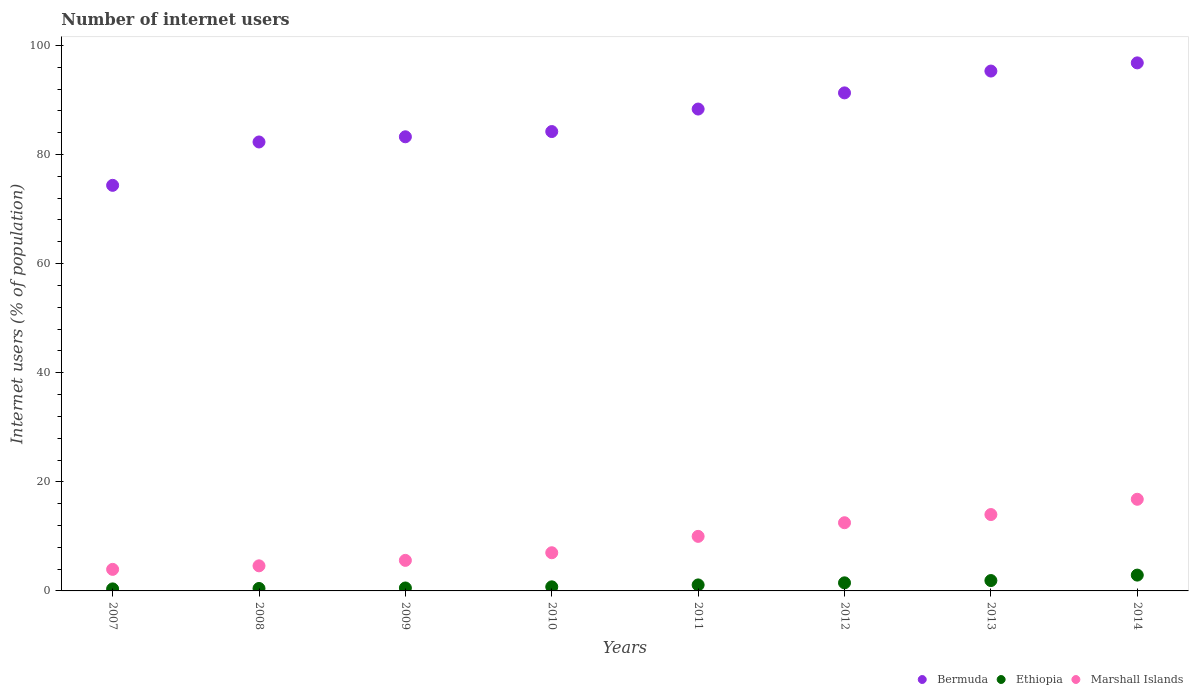Is the number of dotlines equal to the number of legend labels?
Make the answer very short. Yes. What is the number of internet users in Bermuda in 2010?
Provide a succinct answer. 84.21. Across all years, what is the maximum number of internet users in Ethiopia?
Offer a terse response. 2.9. Across all years, what is the minimum number of internet users in Marshall Islands?
Ensure brevity in your answer.  3.95. In which year was the number of internet users in Bermuda maximum?
Your answer should be compact. 2014. In which year was the number of internet users in Bermuda minimum?
Ensure brevity in your answer.  2007. What is the total number of internet users in Marshall Islands in the graph?
Ensure brevity in your answer.  74.45. What is the difference between the number of internet users in Marshall Islands in 2011 and that in 2013?
Provide a succinct answer. -4. What is the difference between the number of internet users in Marshall Islands in 2013 and the number of internet users in Ethiopia in 2008?
Provide a succinct answer. 13.55. What is the average number of internet users in Marshall Islands per year?
Provide a succinct answer. 9.31. In the year 2008, what is the difference between the number of internet users in Bermuda and number of internet users in Ethiopia?
Keep it short and to the point. 81.85. What is the ratio of the number of internet users in Bermuda in 2009 to that in 2012?
Keep it short and to the point. 0.91. Is the difference between the number of internet users in Bermuda in 2009 and 2012 greater than the difference between the number of internet users in Ethiopia in 2009 and 2012?
Provide a short and direct response. No. What is the difference between the highest and the second highest number of internet users in Bermuda?
Make the answer very short. 1.5. What is the difference between the highest and the lowest number of internet users in Bermuda?
Your answer should be compact. 22.45. Is the number of internet users in Marshall Islands strictly greater than the number of internet users in Ethiopia over the years?
Offer a very short reply. Yes. How many years are there in the graph?
Offer a very short reply. 8. Does the graph contain any zero values?
Offer a terse response. No. Where does the legend appear in the graph?
Give a very brief answer. Bottom right. How many legend labels are there?
Your answer should be very brief. 3. How are the legend labels stacked?
Provide a short and direct response. Horizontal. What is the title of the graph?
Your response must be concise. Number of internet users. What is the label or title of the Y-axis?
Make the answer very short. Internet users (% of population). What is the Internet users (% of population) in Bermuda in 2007?
Your answer should be very brief. 74.35. What is the Internet users (% of population) in Ethiopia in 2007?
Provide a succinct answer. 0.37. What is the Internet users (% of population) of Marshall Islands in 2007?
Your answer should be compact. 3.95. What is the Internet users (% of population) in Bermuda in 2008?
Provide a succinct answer. 82.3. What is the Internet users (% of population) in Ethiopia in 2008?
Your answer should be very brief. 0.45. What is the Internet users (% of population) of Marshall Islands in 2008?
Ensure brevity in your answer.  4.6. What is the Internet users (% of population) of Bermuda in 2009?
Make the answer very short. 83.25. What is the Internet users (% of population) in Ethiopia in 2009?
Ensure brevity in your answer.  0.54. What is the Internet users (% of population) in Bermuda in 2010?
Keep it short and to the point. 84.21. What is the Internet users (% of population) in Bermuda in 2011?
Offer a very short reply. 88.34. What is the Internet users (% of population) in Ethiopia in 2011?
Your response must be concise. 1.1. What is the Internet users (% of population) of Bermuda in 2012?
Your response must be concise. 91.3. What is the Internet users (% of population) in Ethiopia in 2012?
Provide a short and direct response. 1.48. What is the Internet users (% of population) of Bermuda in 2013?
Your answer should be compact. 95.3. What is the Internet users (% of population) of Marshall Islands in 2013?
Your answer should be very brief. 14. What is the Internet users (% of population) of Bermuda in 2014?
Provide a short and direct response. 96.8. Across all years, what is the maximum Internet users (% of population) of Bermuda?
Provide a succinct answer. 96.8. Across all years, what is the maximum Internet users (% of population) of Marshall Islands?
Your response must be concise. 16.8. Across all years, what is the minimum Internet users (% of population) of Bermuda?
Your answer should be very brief. 74.35. Across all years, what is the minimum Internet users (% of population) in Ethiopia?
Offer a very short reply. 0.37. Across all years, what is the minimum Internet users (% of population) of Marshall Islands?
Give a very brief answer. 3.95. What is the total Internet users (% of population) in Bermuda in the graph?
Your response must be concise. 695.85. What is the total Internet users (% of population) in Ethiopia in the graph?
Give a very brief answer. 9.49. What is the total Internet users (% of population) of Marshall Islands in the graph?
Offer a very short reply. 74.45. What is the difference between the Internet users (% of population) of Bermuda in 2007 and that in 2008?
Offer a very short reply. -7.95. What is the difference between the Internet users (% of population) of Ethiopia in 2007 and that in 2008?
Provide a succinct answer. -0.08. What is the difference between the Internet users (% of population) in Marshall Islands in 2007 and that in 2008?
Offer a terse response. -0.65. What is the difference between the Internet users (% of population) of Bermuda in 2007 and that in 2009?
Your response must be concise. -8.9. What is the difference between the Internet users (% of population) of Ethiopia in 2007 and that in 2009?
Provide a short and direct response. -0.17. What is the difference between the Internet users (% of population) of Marshall Islands in 2007 and that in 2009?
Offer a very short reply. -1.65. What is the difference between the Internet users (% of population) in Bermuda in 2007 and that in 2010?
Provide a succinct answer. -9.86. What is the difference between the Internet users (% of population) in Ethiopia in 2007 and that in 2010?
Give a very brief answer. -0.38. What is the difference between the Internet users (% of population) in Marshall Islands in 2007 and that in 2010?
Give a very brief answer. -3.05. What is the difference between the Internet users (% of population) of Bermuda in 2007 and that in 2011?
Your answer should be very brief. -13.99. What is the difference between the Internet users (% of population) in Ethiopia in 2007 and that in 2011?
Make the answer very short. -0.73. What is the difference between the Internet users (% of population) of Marshall Islands in 2007 and that in 2011?
Keep it short and to the point. -6.05. What is the difference between the Internet users (% of population) in Bermuda in 2007 and that in 2012?
Keep it short and to the point. -16.95. What is the difference between the Internet users (% of population) in Ethiopia in 2007 and that in 2012?
Keep it short and to the point. -1.11. What is the difference between the Internet users (% of population) of Marshall Islands in 2007 and that in 2012?
Give a very brief answer. -8.55. What is the difference between the Internet users (% of population) in Bermuda in 2007 and that in 2013?
Provide a succinct answer. -20.95. What is the difference between the Internet users (% of population) in Ethiopia in 2007 and that in 2013?
Your answer should be very brief. -1.53. What is the difference between the Internet users (% of population) in Marshall Islands in 2007 and that in 2013?
Give a very brief answer. -10.05. What is the difference between the Internet users (% of population) of Bermuda in 2007 and that in 2014?
Offer a terse response. -22.45. What is the difference between the Internet users (% of population) in Ethiopia in 2007 and that in 2014?
Keep it short and to the point. -2.53. What is the difference between the Internet users (% of population) in Marshall Islands in 2007 and that in 2014?
Your answer should be very brief. -12.85. What is the difference between the Internet users (% of population) of Bermuda in 2008 and that in 2009?
Provide a short and direct response. -0.95. What is the difference between the Internet users (% of population) in Ethiopia in 2008 and that in 2009?
Provide a succinct answer. -0.09. What is the difference between the Internet users (% of population) in Marshall Islands in 2008 and that in 2009?
Keep it short and to the point. -1. What is the difference between the Internet users (% of population) in Bermuda in 2008 and that in 2010?
Make the answer very short. -1.91. What is the difference between the Internet users (% of population) in Bermuda in 2008 and that in 2011?
Provide a short and direct response. -6.04. What is the difference between the Internet users (% of population) of Ethiopia in 2008 and that in 2011?
Keep it short and to the point. -0.65. What is the difference between the Internet users (% of population) of Marshall Islands in 2008 and that in 2011?
Ensure brevity in your answer.  -5.4. What is the difference between the Internet users (% of population) of Bermuda in 2008 and that in 2012?
Offer a terse response. -9. What is the difference between the Internet users (% of population) of Ethiopia in 2008 and that in 2012?
Provide a short and direct response. -1.03. What is the difference between the Internet users (% of population) of Marshall Islands in 2008 and that in 2012?
Your response must be concise. -7.9. What is the difference between the Internet users (% of population) of Bermuda in 2008 and that in 2013?
Keep it short and to the point. -13. What is the difference between the Internet users (% of population) in Ethiopia in 2008 and that in 2013?
Your answer should be very brief. -1.45. What is the difference between the Internet users (% of population) in Marshall Islands in 2008 and that in 2013?
Give a very brief answer. -9.4. What is the difference between the Internet users (% of population) in Bermuda in 2008 and that in 2014?
Your answer should be very brief. -14.5. What is the difference between the Internet users (% of population) in Ethiopia in 2008 and that in 2014?
Provide a short and direct response. -2.45. What is the difference between the Internet users (% of population) in Marshall Islands in 2008 and that in 2014?
Your response must be concise. -12.2. What is the difference between the Internet users (% of population) of Bermuda in 2009 and that in 2010?
Offer a very short reply. -0.96. What is the difference between the Internet users (% of population) in Ethiopia in 2009 and that in 2010?
Provide a succinct answer. -0.21. What is the difference between the Internet users (% of population) of Bermuda in 2009 and that in 2011?
Give a very brief answer. -5.09. What is the difference between the Internet users (% of population) in Ethiopia in 2009 and that in 2011?
Ensure brevity in your answer.  -0.56. What is the difference between the Internet users (% of population) in Bermuda in 2009 and that in 2012?
Keep it short and to the point. -8.05. What is the difference between the Internet users (% of population) in Ethiopia in 2009 and that in 2012?
Provide a succinct answer. -0.94. What is the difference between the Internet users (% of population) in Marshall Islands in 2009 and that in 2012?
Keep it short and to the point. -6.9. What is the difference between the Internet users (% of population) of Bermuda in 2009 and that in 2013?
Your answer should be compact. -12.05. What is the difference between the Internet users (% of population) of Ethiopia in 2009 and that in 2013?
Provide a succinct answer. -1.36. What is the difference between the Internet users (% of population) in Marshall Islands in 2009 and that in 2013?
Your response must be concise. -8.4. What is the difference between the Internet users (% of population) of Bermuda in 2009 and that in 2014?
Provide a short and direct response. -13.55. What is the difference between the Internet users (% of population) in Ethiopia in 2009 and that in 2014?
Your response must be concise. -2.36. What is the difference between the Internet users (% of population) in Bermuda in 2010 and that in 2011?
Your response must be concise. -4.13. What is the difference between the Internet users (% of population) of Ethiopia in 2010 and that in 2011?
Offer a terse response. -0.35. What is the difference between the Internet users (% of population) of Marshall Islands in 2010 and that in 2011?
Keep it short and to the point. -3. What is the difference between the Internet users (% of population) of Bermuda in 2010 and that in 2012?
Provide a short and direct response. -7.09. What is the difference between the Internet users (% of population) in Ethiopia in 2010 and that in 2012?
Offer a very short reply. -0.73. What is the difference between the Internet users (% of population) of Marshall Islands in 2010 and that in 2012?
Provide a short and direct response. -5.5. What is the difference between the Internet users (% of population) in Bermuda in 2010 and that in 2013?
Offer a terse response. -11.09. What is the difference between the Internet users (% of population) in Ethiopia in 2010 and that in 2013?
Make the answer very short. -1.15. What is the difference between the Internet users (% of population) in Bermuda in 2010 and that in 2014?
Keep it short and to the point. -12.59. What is the difference between the Internet users (% of population) in Ethiopia in 2010 and that in 2014?
Provide a short and direct response. -2.15. What is the difference between the Internet users (% of population) of Marshall Islands in 2010 and that in 2014?
Offer a very short reply. -9.8. What is the difference between the Internet users (% of population) of Bermuda in 2011 and that in 2012?
Your answer should be compact. -2.96. What is the difference between the Internet users (% of population) of Ethiopia in 2011 and that in 2012?
Your answer should be compact. -0.38. What is the difference between the Internet users (% of population) in Bermuda in 2011 and that in 2013?
Your response must be concise. -6.96. What is the difference between the Internet users (% of population) in Ethiopia in 2011 and that in 2013?
Your answer should be very brief. -0.8. What is the difference between the Internet users (% of population) of Marshall Islands in 2011 and that in 2013?
Keep it short and to the point. -4. What is the difference between the Internet users (% of population) of Bermuda in 2011 and that in 2014?
Provide a succinct answer. -8.46. What is the difference between the Internet users (% of population) in Marshall Islands in 2011 and that in 2014?
Provide a succinct answer. -6.8. What is the difference between the Internet users (% of population) of Bermuda in 2012 and that in 2013?
Provide a short and direct response. -4. What is the difference between the Internet users (% of population) of Ethiopia in 2012 and that in 2013?
Provide a short and direct response. -0.42. What is the difference between the Internet users (% of population) in Marshall Islands in 2012 and that in 2013?
Ensure brevity in your answer.  -1.5. What is the difference between the Internet users (% of population) in Bermuda in 2012 and that in 2014?
Provide a short and direct response. -5.5. What is the difference between the Internet users (% of population) of Ethiopia in 2012 and that in 2014?
Ensure brevity in your answer.  -1.42. What is the difference between the Internet users (% of population) in Ethiopia in 2013 and that in 2014?
Your answer should be very brief. -1. What is the difference between the Internet users (% of population) of Bermuda in 2007 and the Internet users (% of population) of Ethiopia in 2008?
Give a very brief answer. 73.9. What is the difference between the Internet users (% of population) of Bermuda in 2007 and the Internet users (% of population) of Marshall Islands in 2008?
Keep it short and to the point. 69.75. What is the difference between the Internet users (% of population) of Ethiopia in 2007 and the Internet users (% of population) of Marshall Islands in 2008?
Your response must be concise. -4.23. What is the difference between the Internet users (% of population) in Bermuda in 2007 and the Internet users (% of population) in Ethiopia in 2009?
Offer a very short reply. 73.81. What is the difference between the Internet users (% of population) of Bermuda in 2007 and the Internet users (% of population) of Marshall Islands in 2009?
Provide a short and direct response. 68.75. What is the difference between the Internet users (% of population) of Ethiopia in 2007 and the Internet users (% of population) of Marshall Islands in 2009?
Your answer should be compact. -5.23. What is the difference between the Internet users (% of population) of Bermuda in 2007 and the Internet users (% of population) of Ethiopia in 2010?
Provide a short and direct response. 73.6. What is the difference between the Internet users (% of population) of Bermuda in 2007 and the Internet users (% of population) of Marshall Islands in 2010?
Your answer should be compact. 67.35. What is the difference between the Internet users (% of population) in Ethiopia in 2007 and the Internet users (% of population) in Marshall Islands in 2010?
Offer a very short reply. -6.63. What is the difference between the Internet users (% of population) of Bermuda in 2007 and the Internet users (% of population) of Ethiopia in 2011?
Make the answer very short. 73.25. What is the difference between the Internet users (% of population) in Bermuda in 2007 and the Internet users (% of population) in Marshall Islands in 2011?
Provide a succinct answer. 64.35. What is the difference between the Internet users (% of population) of Ethiopia in 2007 and the Internet users (% of population) of Marshall Islands in 2011?
Your response must be concise. -9.63. What is the difference between the Internet users (% of population) in Bermuda in 2007 and the Internet users (% of population) in Ethiopia in 2012?
Give a very brief answer. 72.87. What is the difference between the Internet users (% of population) of Bermuda in 2007 and the Internet users (% of population) of Marshall Islands in 2012?
Your response must be concise. 61.85. What is the difference between the Internet users (% of population) in Ethiopia in 2007 and the Internet users (% of population) in Marshall Islands in 2012?
Provide a succinct answer. -12.13. What is the difference between the Internet users (% of population) of Bermuda in 2007 and the Internet users (% of population) of Ethiopia in 2013?
Your response must be concise. 72.45. What is the difference between the Internet users (% of population) in Bermuda in 2007 and the Internet users (% of population) in Marshall Islands in 2013?
Give a very brief answer. 60.35. What is the difference between the Internet users (% of population) of Ethiopia in 2007 and the Internet users (% of population) of Marshall Islands in 2013?
Your answer should be compact. -13.63. What is the difference between the Internet users (% of population) of Bermuda in 2007 and the Internet users (% of population) of Ethiopia in 2014?
Give a very brief answer. 71.45. What is the difference between the Internet users (% of population) in Bermuda in 2007 and the Internet users (% of population) in Marshall Islands in 2014?
Make the answer very short. 57.55. What is the difference between the Internet users (% of population) in Ethiopia in 2007 and the Internet users (% of population) in Marshall Islands in 2014?
Your answer should be very brief. -16.43. What is the difference between the Internet users (% of population) in Bermuda in 2008 and the Internet users (% of population) in Ethiopia in 2009?
Keep it short and to the point. 81.76. What is the difference between the Internet users (% of population) in Bermuda in 2008 and the Internet users (% of population) in Marshall Islands in 2009?
Keep it short and to the point. 76.7. What is the difference between the Internet users (% of population) in Ethiopia in 2008 and the Internet users (% of population) in Marshall Islands in 2009?
Offer a very short reply. -5.15. What is the difference between the Internet users (% of population) of Bermuda in 2008 and the Internet users (% of population) of Ethiopia in 2010?
Your answer should be compact. 81.55. What is the difference between the Internet users (% of population) in Bermuda in 2008 and the Internet users (% of population) in Marshall Islands in 2010?
Your answer should be very brief. 75.3. What is the difference between the Internet users (% of population) of Ethiopia in 2008 and the Internet users (% of population) of Marshall Islands in 2010?
Your answer should be very brief. -6.55. What is the difference between the Internet users (% of population) of Bermuda in 2008 and the Internet users (% of population) of Ethiopia in 2011?
Ensure brevity in your answer.  81.2. What is the difference between the Internet users (% of population) of Bermuda in 2008 and the Internet users (% of population) of Marshall Islands in 2011?
Make the answer very short. 72.3. What is the difference between the Internet users (% of population) in Ethiopia in 2008 and the Internet users (% of population) in Marshall Islands in 2011?
Your response must be concise. -9.55. What is the difference between the Internet users (% of population) in Bermuda in 2008 and the Internet users (% of population) in Ethiopia in 2012?
Ensure brevity in your answer.  80.82. What is the difference between the Internet users (% of population) in Bermuda in 2008 and the Internet users (% of population) in Marshall Islands in 2012?
Your answer should be compact. 69.8. What is the difference between the Internet users (% of population) in Ethiopia in 2008 and the Internet users (% of population) in Marshall Islands in 2012?
Offer a terse response. -12.05. What is the difference between the Internet users (% of population) of Bermuda in 2008 and the Internet users (% of population) of Ethiopia in 2013?
Offer a very short reply. 80.4. What is the difference between the Internet users (% of population) in Bermuda in 2008 and the Internet users (% of population) in Marshall Islands in 2013?
Keep it short and to the point. 68.3. What is the difference between the Internet users (% of population) of Ethiopia in 2008 and the Internet users (% of population) of Marshall Islands in 2013?
Provide a short and direct response. -13.55. What is the difference between the Internet users (% of population) of Bermuda in 2008 and the Internet users (% of population) of Ethiopia in 2014?
Your response must be concise. 79.4. What is the difference between the Internet users (% of population) of Bermuda in 2008 and the Internet users (% of population) of Marshall Islands in 2014?
Keep it short and to the point. 65.5. What is the difference between the Internet users (% of population) in Ethiopia in 2008 and the Internet users (% of population) in Marshall Islands in 2014?
Your response must be concise. -16.35. What is the difference between the Internet users (% of population) in Bermuda in 2009 and the Internet users (% of population) in Ethiopia in 2010?
Your answer should be very brief. 82.5. What is the difference between the Internet users (% of population) in Bermuda in 2009 and the Internet users (% of population) in Marshall Islands in 2010?
Give a very brief answer. 76.25. What is the difference between the Internet users (% of population) in Ethiopia in 2009 and the Internet users (% of population) in Marshall Islands in 2010?
Your response must be concise. -6.46. What is the difference between the Internet users (% of population) of Bermuda in 2009 and the Internet users (% of population) of Ethiopia in 2011?
Provide a short and direct response. 82.15. What is the difference between the Internet users (% of population) of Bermuda in 2009 and the Internet users (% of population) of Marshall Islands in 2011?
Keep it short and to the point. 73.25. What is the difference between the Internet users (% of population) of Ethiopia in 2009 and the Internet users (% of population) of Marshall Islands in 2011?
Your answer should be compact. -9.46. What is the difference between the Internet users (% of population) of Bermuda in 2009 and the Internet users (% of population) of Ethiopia in 2012?
Your response must be concise. 81.77. What is the difference between the Internet users (% of population) of Bermuda in 2009 and the Internet users (% of population) of Marshall Islands in 2012?
Your answer should be very brief. 70.75. What is the difference between the Internet users (% of population) of Ethiopia in 2009 and the Internet users (% of population) of Marshall Islands in 2012?
Your answer should be very brief. -11.96. What is the difference between the Internet users (% of population) of Bermuda in 2009 and the Internet users (% of population) of Ethiopia in 2013?
Offer a terse response. 81.35. What is the difference between the Internet users (% of population) of Bermuda in 2009 and the Internet users (% of population) of Marshall Islands in 2013?
Make the answer very short. 69.25. What is the difference between the Internet users (% of population) in Ethiopia in 2009 and the Internet users (% of population) in Marshall Islands in 2013?
Your response must be concise. -13.46. What is the difference between the Internet users (% of population) of Bermuda in 2009 and the Internet users (% of population) of Ethiopia in 2014?
Keep it short and to the point. 80.35. What is the difference between the Internet users (% of population) in Bermuda in 2009 and the Internet users (% of population) in Marshall Islands in 2014?
Make the answer very short. 66.45. What is the difference between the Internet users (% of population) of Ethiopia in 2009 and the Internet users (% of population) of Marshall Islands in 2014?
Provide a short and direct response. -16.26. What is the difference between the Internet users (% of population) of Bermuda in 2010 and the Internet users (% of population) of Ethiopia in 2011?
Make the answer very short. 83.11. What is the difference between the Internet users (% of population) in Bermuda in 2010 and the Internet users (% of population) in Marshall Islands in 2011?
Offer a very short reply. 74.21. What is the difference between the Internet users (% of population) in Ethiopia in 2010 and the Internet users (% of population) in Marshall Islands in 2011?
Ensure brevity in your answer.  -9.25. What is the difference between the Internet users (% of population) in Bermuda in 2010 and the Internet users (% of population) in Ethiopia in 2012?
Offer a very short reply. 82.73. What is the difference between the Internet users (% of population) in Bermuda in 2010 and the Internet users (% of population) in Marshall Islands in 2012?
Keep it short and to the point. 71.71. What is the difference between the Internet users (% of population) of Ethiopia in 2010 and the Internet users (% of population) of Marshall Islands in 2012?
Keep it short and to the point. -11.75. What is the difference between the Internet users (% of population) in Bermuda in 2010 and the Internet users (% of population) in Ethiopia in 2013?
Your answer should be very brief. 82.31. What is the difference between the Internet users (% of population) of Bermuda in 2010 and the Internet users (% of population) of Marshall Islands in 2013?
Offer a very short reply. 70.21. What is the difference between the Internet users (% of population) of Ethiopia in 2010 and the Internet users (% of population) of Marshall Islands in 2013?
Ensure brevity in your answer.  -13.25. What is the difference between the Internet users (% of population) in Bermuda in 2010 and the Internet users (% of population) in Ethiopia in 2014?
Make the answer very short. 81.31. What is the difference between the Internet users (% of population) in Bermuda in 2010 and the Internet users (% of population) in Marshall Islands in 2014?
Your response must be concise. 67.41. What is the difference between the Internet users (% of population) in Ethiopia in 2010 and the Internet users (% of population) in Marshall Islands in 2014?
Ensure brevity in your answer.  -16.05. What is the difference between the Internet users (% of population) in Bermuda in 2011 and the Internet users (% of population) in Ethiopia in 2012?
Your answer should be compact. 86.85. What is the difference between the Internet users (% of population) in Bermuda in 2011 and the Internet users (% of population) in Marshall Islands in 2012?
Make the answer very short. 75.84. What is the difference between the Internet users (% of population) in Bermuda in 2011 and the Internet users (% of population) in Ethiopia in 2013?
Give a very brief answer. 86.44. What is the difference between the Internet users (% of population) in Bermuda in 2011 and the Internet users (% of population) in Marshall Islands in 2013?
Provide a short and direct response. 74.34. What is the difference between the Internet users (% of population) of Bermuda in 2011 and the Internet users (% of population) of Ethiopia in 2014?
Your answer should be very brief. 85.44. What is the difference between the Internet users (% of population) in Bermuda in 2011 and the Internet users (% of population) in Marshall Islands in 2014?
Ensure brevity in your answer.  71.54. What is the difference between the Internet users (% of population) in Ethiopia in 2011 and the Internet users (% of population) in Marshall Islands in 2014?
Your answer should be very brief. -15.7. What is the difference between the Internet users (% of population) of Bermuda in 2012 and the Internet users (% of population) of Ethiopia in 2013?
Offer a very short reply. 89.4. What is the difference between the Internet users (% of population) in Bermuda in 2012 and the Internet users (% of population) in Marshall Islands in 2013?
Make the answer very short. 77.3. What is the difference between the Internet users (% of population) of Ethiopia in 2012 and the Internet users (% of population) of Marshall Islands in 2013?
Keep it short and to the point. -12.52. What is the difference between the Internet users (% of population) of Bermuda in 2012 and the Internet users (% of population) of Ethiopia in 2014?
Give a very brief answer. 88.4. What is the difference between the Internet users (% of population) in Bermuda in 2012 and the Internet users (% of population) in Marshall Islands in 2014?
Your answer should be very brief. 74.5. What is the difference between the Internet users (% of population) in Ethiopia in 2012 and the Internet users (% of population) in Marshall Islands in 2014?
Your answer should be very brief. -15.32. What is the difference between the Internet users (% of population) of Bermuda in 2013 and the Internet users (% of population) of Ethiopia in 2014?
Offer a terse response. 92.4. What is the difference between the Internet users (% of population) in Bermuda in 2013 and the Internet users (% of population) in Marshall Islands in 2014?
Ensure brevity in your answer.  78.5. What is the difference between the Internet users (% of population) in Ethiopia in 2013 and the Internet users (% of population) in Marshall Islands in 2014?
Offer a terse response. -14.9. What is the average Internet users (% of population) in Bermuda per year?
Ensure brevity in your answer.  86.98. What is the average Internet users (% of population) in Ethiopia per year?
Provide a succinct answer. 1.19. What is the average Internet users (% of population) of Marshall Islands per year?
Offer a very short reply. 9.31. In the year 2007, what is the difference between the Internet users (% of population) of Bermuda and Internet users (% of population) of Ethiopia?
Ensure brevity in your answer.  73.98. In the year 2007, what is the difference between the Internet users (% of population) in Bermuda and Internet users (% of population) in Marshall Islands?
Give a very brief answer. 70.4. In the year 2007, what is the difference between the Internet users (% of population) in Ethiopia and Internet users (% of population) in Marshall Islands?
Your response must be concise. -3.58. In the year 2008, what is the difference between the Internet users (% of population) of Bermuda and Internet users (% of population) of Ethiopia?
Provide a short and direct response. 81.85. In the year 2008, what is the difference between the Internet users (% of population) in Bermuda and Internet users (% of population) in Marshall Islands?
Offer a terse response. 77.7. In the year 2008, what is the difference between the Internet users (% of population) of Ethiopia and Internet users (% of population) of Marshall Islands?
Give a very brief answer. -4.15. In the year 2009, what is the difference between the Internet users (% of population) in Bermuda and Internet users (% of population) in Ethiopia?
Your answer should be very brief. 82.71. In the year 2009, what is the difference between the Internet users (% of population) in Bermuda and Internet users (% of population) in Marshall Islands?
Ensure brevity in your answer.  77.65. In the year 2009, what is the difference between the Internet users (% of population) of Ethiopia and Internet users (% of population) of Marshall Islands?
Ensure brevity in your answer.  -5.06. In the year 2010, what is the difference between the Internet users (% of population) of Bermuda and Internet users (% of population) of Ethiopia?
Ensure brevity in your answer.  83.46. In the year 2010, what is the difference between the Internet users (% of population) of Bermuda and Internet users (% of population) of Marshall Islands?
Ensure brevity in your answer.  77.21. In the year 2010, what is the difference between the Internet users (% of population) of Ethiopia and Internet users (% of population) of Marshall Islands?
Keep it short and to the point. -6.25. In the year 2011, what is the difference between the Internet users (% of population) in Bermuda and Internet users (% of population) in Ethiopia?
Your answer should be compact. 87.24. In the year 2011, what is the difference between the Internet users (% of population) in Bermuda and Internet users (% of population) in Marshall Islands?
Ensure brevity in your answer.  78.34. In the year 2012, what is the difference between the Internet users (% of population) of Bermuda and Internet users (% of population) of Ethiopia?
Give a very brief answer. 89.82. In the year 2012, what is the difference between the Internet users (% of population) in Bermuda and Internet users (% of population) in Marshall Islands?
Give a very brief answer. 78.8. In the year 2012, what is the difference between the Internet users (% of population) in Ethiopia and Internet users (% of population) in Marshall Islands?
Keep it short and to the point. -11.02. In the year 2013, what is the difference between the Internet users (% of population) of Bermuda and Internet users (% of population) of Ethiopia?
Ensure brevity in your answer.  93.4. In the year 2013, what is the difference between the Internet users (% of population) in Bermuda and Internet users (% of population) in Marshall Islands?
Provide a short and direct response. 81.3. In the year 2013, what is the difference between the Internet users (% of population) of Ethiopia and Internet users (% of population) of Marshall Islands?
Keep it short and to the point. -12.1. In the year 2014, what is the difference between the Internet users (% of population) of Bermuda and Internet users (% of population) of Ethiopia?
Offer a very short reply. 93.9. In the year 2014, what is the difference between the Internet users (% of population) in Bermuda and Internet users (% of population) in Marshall Islands?
Ensure brevity in your answer.  80. In the year 2014, what is the difference between the Internet users (% of population) in Ethiopia and Internet users (% of population) in Marshall Islands?
Ensure brevity in your answer.  -13.9. What is the ratio of the Internet users (% of population) of Bermuda in 2007 to that in 2008?
Your response must be concise. 0.9. What is the ratio of the Internet users (% of population) in Ethiopia in 2007 to that in 2008?
Keep it short and to the point. 0.82. What is the ratio of the Internet users (% of population) of Marshall Islands in 2007 to that in 2008?
Provide a short and direct response. 0.86. What is the ratio of the Internet users (% of population) of Bermuda in 2007 to that in 2009?
Offer a very short reply. 0.89. What is the ratio of the Internet users (% of population) of Ethiopia in 2007 to that in 2009?
Keep it short and to the point. 0.69. What is the ratio of the Internet users (% of population) of Marshall Islands in 2007 to that in 2009?
Your answer should be compact. 0.71. What is the ratio of the Internet users (% of population) of Bermuda in 2007 to that in 2010?
Your response must be concise. 0.88. What is the ratio of the Internet users (% of population) in Ethiopia in 2007 to that in 2010?
Ensure brevity in your answer.  0.49. What is the ratio of the Internet users (% of population) of Marshall Islands in 2007 to that in 2010?
Ensure brevity in your answer.  0.56. What is the ratio of the Internet users (% of population) of Bermuda in 2007 to that in 2011?
Ensure brevity in your answer.  0.84. What is the ratio of the Internet users (% of population) in Ethiopia in 2007 to that in 2011?
Ensure brevity in your answer.  0.34. What is the ratio of the Internet users (% of population) of Marshall Islands in 2007 to that in 2011?
Offer a very short reply. 0.4. What is the ratio of the Internet users (% of population) in Bermuda in 2007 to that in 2012?
Your answer should be compact. 0.81. What is the ratio of the Internet users (% of population) in Ethiopia in 2007 to that in 2012?
Keep it short and to the point. 0.25. What is the ratio of the Internet users (% of population) in Marshall Islands in 2007 to that in 2012?
Your answer should be compact. 0.32. What is the ratio of the Internet users (% of population) in Bermuda in 2007 to that in 2013?
Provide a short and direct response. 0.78. What is the ratio of the Internet users (% of population) of Ethiopia in 2007 to that in 2013?
Provide a short and direct response. 0.19. What is the ratio of the Internet users (% of population) of Marshall Islands in 2007 to that in 2013?
Your answer should be compact. 0.28. What is the ratio of the Internet users (% of population) in Bermuda in 2007 to that in 2014?
Give a very brief answer. 0.77. What is the ratio of the Internet users (% of population) of Ethiopia in 2007 to that in 2014?
Your answer should be compact. 0.13. What is the ratio of the Internet users (% of population) in Marshall Islands in 2007 to that in 2014?
Make the answer very short. 0.24. What is the ratio of the Internet users (% of population) in Bermuda in 2008 to that in 2009?
Keep it short and to the point. 0.99. What is the ratio of the Internet users (% of population) of Marshall Islands in 2008 to that in 2009?
Provide a succinct answer. 0.82. What is the ratio of the Internet users (% of population) in Bermuda in 2008 to that in 2010?
Your response must be concise. 0.98. What is the ratio of the Internet users (% of population) in Marshall Islands in 2008 to that in 2010?
Provide a short and direct response. 0.66. What is the ratio of the Internet users (% of population) in Bermuda in 2008 to that in 2011?
Give a very brief answer. 0.93. What is the ratio of the Internet users (% of population) in Ethiopia in 2008 to that in 2011?
Provide a succinct answer. 0.41. What is the ratio of the Internet users (% of population) in Marshall Islands in 2008 to that in 2011?
Offer a terse response. 0.46. What is the ratio of the Internet users (% of population) in Bermuda in 2008 to that in 2012?
Ensure brevity in your answer.  0.9. What is the ratio of the Internet users (% of population) of Ethiopia in 2008 to that in 2012?
Your response must be concise. 0.3. What is the ratio of the Internet users (% of population) in Marshall Islands in 2008 to that in 2012?
Offer a very short reply. 0.37. What is the ratio of the Internet users (% of population) in Bermuda in 2008 to that in 2013?
Offer a very short reply. 0.86. What is the ratio of the Internet users (% of population) of Ethiopia in 2008 to that in 2013?
Make the answer very short. 0.24. What is the ratio of the Internet users (% of population) in Marshall Islands in 2008 to that in 2013?
Give a very brief answer. 0.33. What is the ratio of the Internet users (% of population) in Bermuda in 2008 to that in 2014?
Give a very brief answer. 0.85. What is the ratio of the Internet users (% of population) in Ethiopia in 2008 to that in 2014?
Provide a short and direct response. 0.16. What is the ratio of the Internet users (% of population) in Marshall Islands in 2008 to that in 2014?
Give a very brief answer. 0.27. What is the ratio of the Internet users (% of population) in Ethiopia in 2009 to that in 2010?
Your answer should be compact. 0.72. What is the ratio of the Internet users (% of population) of Marshall Islands in 2009 to that in 2010?
Offer a terse response. 0.8. What is the ratio of the Internet users (% of population) of Bermuda in 2009 to that in 2011?
Offer a terse response. 0.94. What is the ratio of the Internet users (% of population) of Ethiopia in 2009 to that in 2011?
Offer a very short reply. 0.49. What is the ratio of the Internet users (% of population) of Marshall Islands in 2009 to that in 2011?
Provide a succinct answer. 0.56. What is the ratio of the Internet users (% of population) of Bermuda in 2009 to that in 2012?
Your answer should be very brief. 0.91. What is the ratio of the Internet users (% of population) of Ethiopia in 2009 to that in 2012?
Offer a very short reply. 0.36. What is the ratio of the Internet users (% of population) of Marshall Islands in 2009 to that in 2012?
Keep it short and to the point. 0.45. What is the ratio of the Internet users (% of population) of Bermuda in 2009 to that in 2013?
Offer a terse response. 0.87. What is the ratio of the Internet users (% of population) in Ethiopia in 2009 to that in 2013?
Keep it short and to the point. 0.28. What is the ratio of the Internet users (% of population) of Bermuda in 2009 to that in 2014?
Your answer should be very brief. 0.86. What is the ratio of the Internet users (% of population) in Ethiopia in 2009 to that in 2014?
Your answer should be very brief. 0.19. What is the ratio of the Internet users (% of population) of Marshall Islands in 2009 to that in 2014?
Keep it short and to the point. 0.33. What is the ratio of the Internet users (% of population) of Bermuda in 2010 to that in 2011?
Ensure brevity in your answer.  0.95. What is the ratio of the Internet users (% of population) of Ethiopia in 2010 to that in 2011?
Make the answer very short. 0.68. What is the ratio of the Internet users (% of population) of Marshall Islands in 2010 to that in 2011?
Give a very brief answer. 0.7. What is the ratio of the Internet users (% of population) in Bermuda in 2010 to that in 2012?
Give a very brief answer. 0.92. What is the ratio of the Internet users (% of population) in Ethiopia in 2010 to that in 2012?
Offer a terse response. 0.51. What is the ratio of the Internet users (% of population) in Marshall Islands in 2010 to that in 2012?
Give a very brief answer. 0.56. What is the ratio of the Internet users (% of population) of Bermuda in 2010 to that in 2013?
Provide a short and direct response. 0.88. What is the ratio of the Internet users (% of population) in Ethiopia in 2010 to that in 2013?
Offer a very short reply. 0.39. What is the ratio of the Internet users (% of population) in Marshall Islands in 2010 to that in 2013?
Your answer should be compact. 0.5. What is the ratio of the Internet users (% of population) in Bermuda in 2010 to that in 2014?
Offer a very short reply. 0.87. What is the ratio of the Internet users (% of population) of Ethiopia in 2010 to that in 2014?
Offer a very short reply. 0.26. What is the ratio of the Internet users (% of population) of Marshall Islands in 2010 to that in 2014?
Give a very brief answer. 0.42. What is the ratio of the Internet users (% of population) in Bermuda in 2011 to that in 2012?
Provide a succinct answer. 0.97. What is the ratio of the Internet users (% of population) in Ethiopia in 2011 to that in 2012?
Ensure brevity in your answer.  0.74. What is the ratio of the Internet users (% of population) of Marshall Islands in 2011 to that in 2012?
Make the answer very short. 0.8. What is the ratio of the Internet users (% of population) of Bermuda in 2011 to that in 2013?
Offer a terse response. 0.93. What is the ratio of the Internet users (% of population) of Ethiopia in 2011 to that in 2013?
Provide a succinct answer. 0.58. What is the ratio of the Internet users (% of population) of Bermuda in 2011 to that in 2014?
Your answer should be compact. 0.91. What is the ratio of the Internet users (% of population) in Ethiopia in 2011 to that in 2014?
Make the answer very short. 0.38. What is the ratio of the Internet users (% of population) in Marshall Islands in 2011 to that in 2014?
Your response must be concise. 0.6. What is the ratio of the Internet users (% of population) in Bermuda in 2012 to that in 2013?
Offer a very short reply. 0.96. What is the ratio of the Internet users (% of population) of Ethiopia in 2012 to that in 2013?
Keep it short and to the point. 0.78. What is the ratio of the Internet users (% of population) of Marshall Islands in 2012 to that in 2013?
Ensure brevity in your answer.  0.89. What is the ratio of the Internet users (% of population) in Bermuda in 2012 to that in 2014?
Provide a short and direct response. 0.94. What is the ratio of the Internet users (% of population) in Ethiopia in 2012 to that in 2014?
Your answer should be very brief. 0.51. What is the ratio of the Internet users (% of population) of Marshall Islands in 2012 to that in 2014?
Offer a very short reply. 0.74. What is the ratio of the Internet users (% of population) in Bermuda in 2013 to that in 2014?
Give a very brief answer. 0.98. What is the ratio of the Internet users (% of population) of Ethiopia in 2013 to that in 2014?
Your answer should be compact. 0.66. What is the difference between the highest and the second highest Internet users (% of population) of Ethiopia?
Keep it short and to the point. 1. What is the difference between the highest and the lowest Internet users (% of population) in Bermuda?
Offer a very short reply. 22.45. What is the difference between the highest and the lowest Internet users (% of population) of Ethiopia?
Offer a very short reply. 2.53. What is the difference between the highest and the lowest Internet users (% of population) of Marshall Islands?
Ensure brevity in your answer.  12.85. 